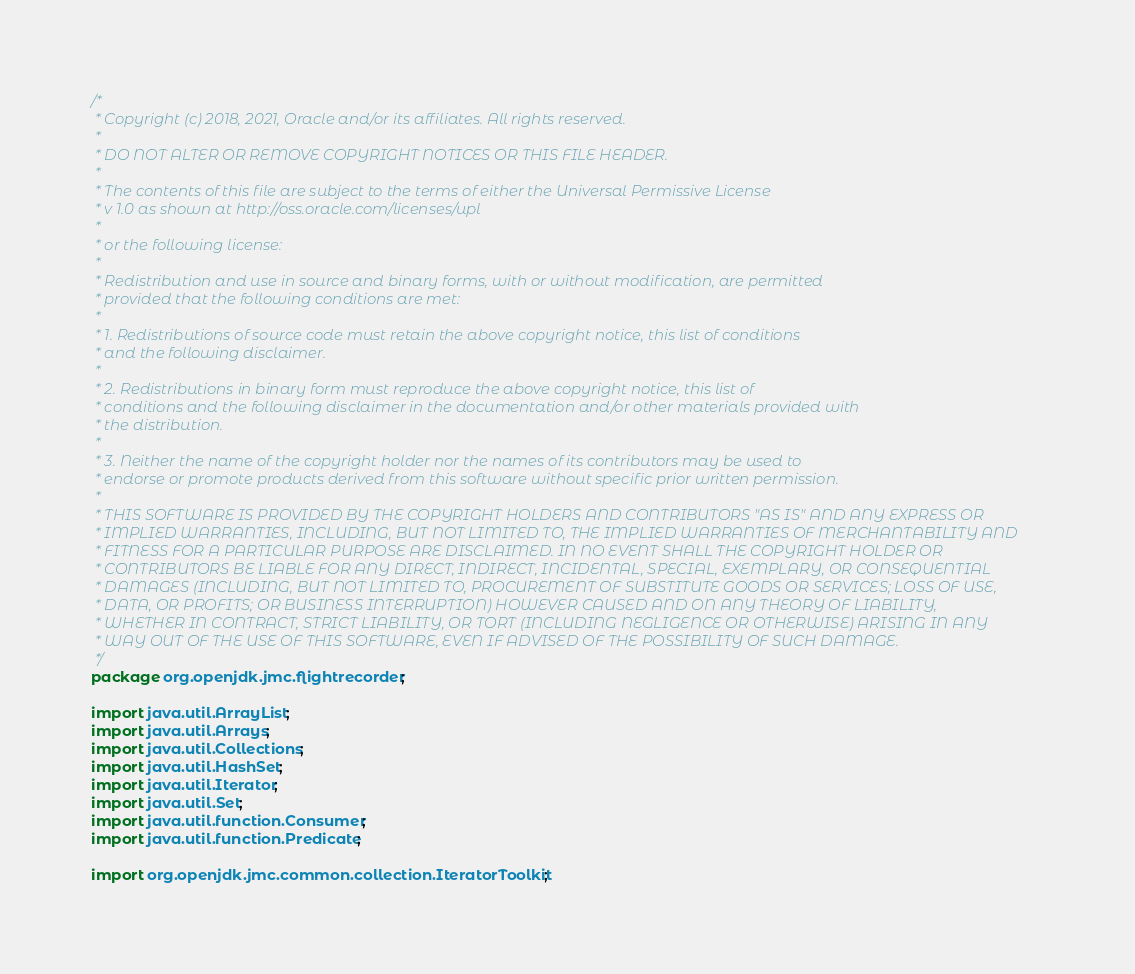<code> <loc_0><loc_0><loc_500><loc_500><_Java_>/*
 * Copyright (c) 2018, 2021, Oracle and/or its affiliates. All rights reserved.
 *
 * DO NOT ALTER OR REMOVE COPYRIGHT NOTICES OR THIS FILE HEADER.
 *
 * The contents of this file are subject to the terms of either the Universal Permissive License
 * v 1.0 as shown at http://oss.oracle.com/licenses/upl
 *
 * or the following license:
 *
 * Redistribution and use in source and binary forms, with or without modification, are permitted
 * provided that the following conditions are met:
 *
 * 1. Redistributions of source code must retain the above copyright notice, this list of conditions
 * and the following disclaimer.
 *
 * 2. Redistributions in binary form must reproduce the above copyright notice, this list of
 * conditions and the following disclaimer in the documentation and/or other materials provided with
 * the distribution.
 *
 * 3. Neither the name of the copyright holder nor the names of its contributors may be used to
 * endorse or promote products derived from this software without specific prior written permission.
 *
 * THIS SOFTWARE IS PROVIDED BY THE COPYRIGHT HOLDERS AND CONTRIBUTORS "AS IS" AND ANY EXPRESS OR
 * IMPLIED WARRANTIES, INCLUDING, BUT NOT LIMITED TO, THE IMPLIED WARRANTIES OF MERCHANTABILITY AND
 * FITNESS FOR A PARTICULAR PURPOSE ARE DISCLAIMED. IN NO EVENT SHALL THE COPYRIGHT HOLDER OR
 * CONTRIBUTORS BE LIABLE FOR ANY DIRECT, INDIRECT, INCIDENTAL, SPECIAL, EXEMPLARY, OR CONSEQUENTIAL
 * DAMAGES (INCLUDING, BUT NOT LIMITED TO, PROCUREMENT OF SUBSTITUTE GOODS OR SERVICES; LOSS OF USE,
 * DATA, OR PROFITS; OR BUSINESS INTERRUPTION) HOWEVER CAUSED AND ON ANY THEORY OF LIABILITY,
 * WHETHER IN CONTRACT, STRICT LIABILITY, OR TORT (INCLUDING NEGLIGENCE OR OTHERWISE) ARISING IN ANY
 * WAY OUT OF THE USE OF THIS SOFTWARE, EVEN IF ADVISED OF THE POSSIBILITY OF SUCH DAMAGE.
 */
package org.openjdk.jmc.flightrecorder;

import java.util.ArrayList;
import java.util.Arrays;
import java.util.Collections;
import java.util.HashSet;
import java.util.Iterator;
import java.util.Set;
import java.util.function.Consumer;
import java.util.function.Predicate;

import org.openjdk.jmc.common.collection.IteratorToolkit;</code> 